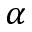Convert formula to latex. <formula><loc_0><loc_0><loc_500><loc_500>\alpha</formula> 